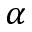Convert formula to latex. <formula><loc_0><loc_0><loc_500><loc_500>\alpha</formula> 